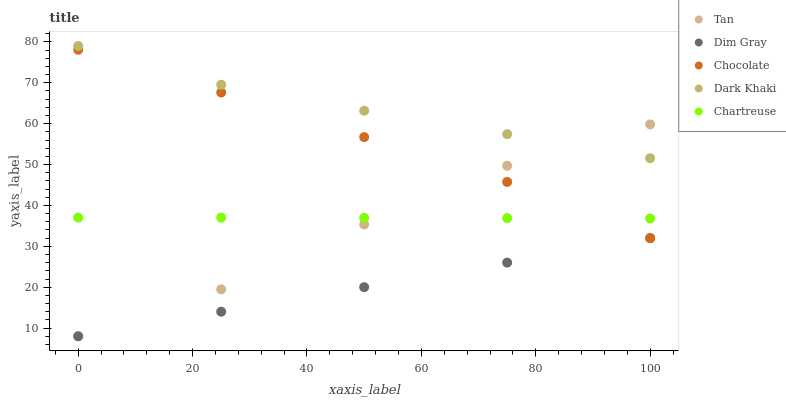Does Dim Gray have the minimum area under the curve?
Answer yes or no. Yes. Does Dark Khaki have the maximum area under the curve?
Answer yes or no. Yes. Does Tan have the minimum area under the curve?
Answer yes or no. No. Does Tan have the maximum area under the curve?
Answer yes or no. No. Is Dim Gray the smoothest?
Answer yes or no. Yes. Is Tan the roughest?
Answer yes or no. Yes. Is Tan the smoothest?
Answer yes or no. No. Is Dim Gray the roughest?
Answer yes or no. No. Does Tan have the lowest value?
Answer yes or no. Yes. Does Chartreuse have the lowest value?
Answer yes or no. No. Does Dark Khaki have the highest value?
Answer yes or no. Yes. Does Tan have the highest value?
Answer yes or no. No. Is Chocolate less than Dark Khaki?
Answer yes or no. Yes. Is Chartreuse greater than Dim Gray?
Answer yes or no. Yes. Does Tan intersect Dark Khaki?
Answer yes or no. Yes. Is Tan less than Dark Khaki?
Answer yes or no. No. Is Tan greater than Dark Khaki?
Answer yes or no. No. Does Chocolate intersect Dark Khaki?
Answer yes or no. No. 